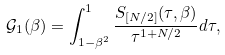Convert formula to latex. <formula><loc_0><loc_0><loc_500><loc_500>\mathcal { G } _ { 1 } ( \beta ) = \int _ { 1 - \beta ^ { 2 } } ^ { 1 } \frac { S _ { [ N / 2 ] } ( \tau , \beta ) } { \tau ^ { 1 + N / 2 } } d \tau ,</formula> 